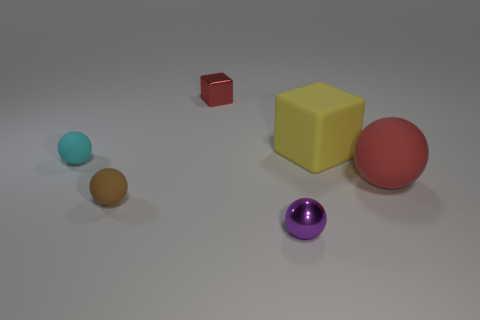Subtract all blue balls. Subtract all yellow cubes. How many balls are left? 4 Add 3 large blue balls. How many objects exist? 9 Subtract all blocks. How many objects are left? 4 Subtract all large brown shiny spheres. Subtract all big matte cubes. How many objects are left? 5 Add 2 large rubber blocks. How many large rubber blocks are left? 3 Add 6 red spheres. How many red spheres exist? 7 Subtract 1 brown balls. How many objects are left? 5 